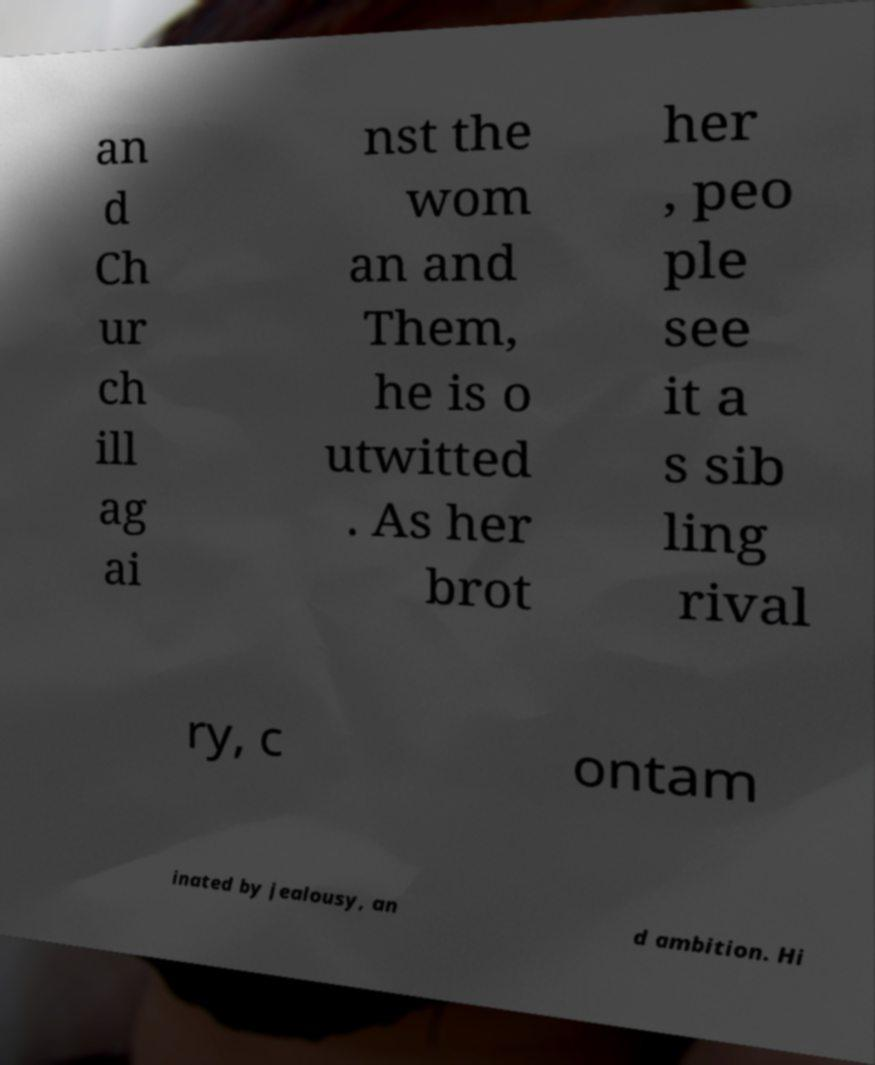Please read and relay the text visible in this image. What does it say? an d Ch ur ch ill ag ai nst the wom an and Them, he is o utwitted . As her brot her , peo ple see it a s sib ling rival ry, c ontam inated by jealousy, an d ambition. Hi 